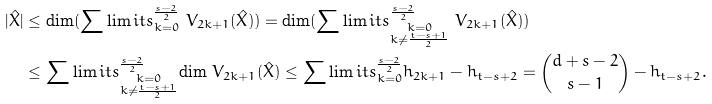<formula> <loc_0><loc_0><loc_500><loc_500>| \hat { X } | & \leq \text {dim} ( \sum \lim i t s _ { k = 0 } ^ { \frac { s - 2 } { 2 } } \ V _ { 2 k + 1 } ( \hat { X } ) ) = \text {dim} ( \sum \lim i t s _ { \substack { k = 0 \\ k \neq \frac { t - s + 1 } { 2 } } } ^ { \frac { s - 2 } { 2 } } \ V _ { 2 k + 1 } ( \hat { X } ) ) \\ & \leq \sum \lim i t s _ { \substack { k = 0 \\ k \neq \frac { t - s + 1 } { 2 } } } ^ { \frac { s - 2 } { 2 } } \text {dim} \ V _ { 2 k + 1 } ( \hat { X } ) \leq \sum \lim i t s _ { k = 0 } ^ { \frac { s - 2 } { 2 } } h _ { 2 k + 1 } - h _ { t - s + 2 } = \binom { d + s - 2 } { s - 1 } - h _ { t - s + 2 } .</formula> 